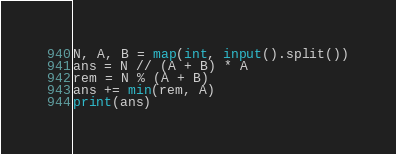<code> <loc_0><loc_0><loc_500><loc_500><_Python_>N, A, B = map(int, input().split())
ans = N // (A + B) * A
rem = N % (A + B)
ans += min(rem, A)
print(ans)
</code> 